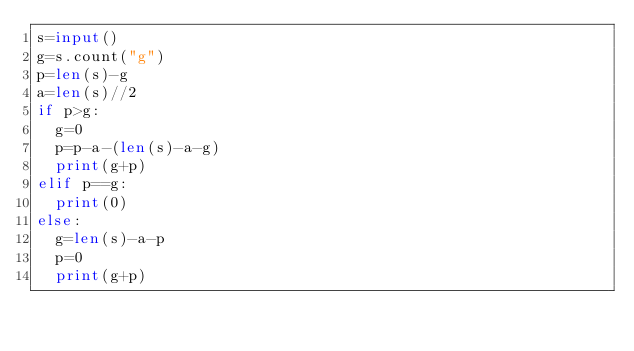Convert code to text. <code><loc_0><loc_0><loc_500><loc_500><_Python_>s=input()
g=s.count("g")
p=len(s)-g
a=len(s)//2
if p>g:
  g=0
  p=p-a-(len(s)-a-g)
  print(g+p)
elif p==g:
  print(0)
else:
  g=len(s)-a-p
  p=0
  print(g+p)</code> 